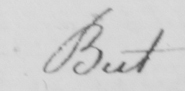Please transcribe the handwritten text in this image. But 